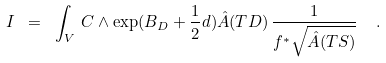Convert formula to latex. <formula><loc_0><loc_0><loc_500><loc_500>I \ = \ \int _ { V } \, C \wedge \exp ( B _ { D } + \frac { 1 } { 2 } d ) \hat { A } ( T D ) \, \frac { 1 } { f ^ { * } \sqrt { \hat { A } ( T S ) } } \ \ .</formula> 